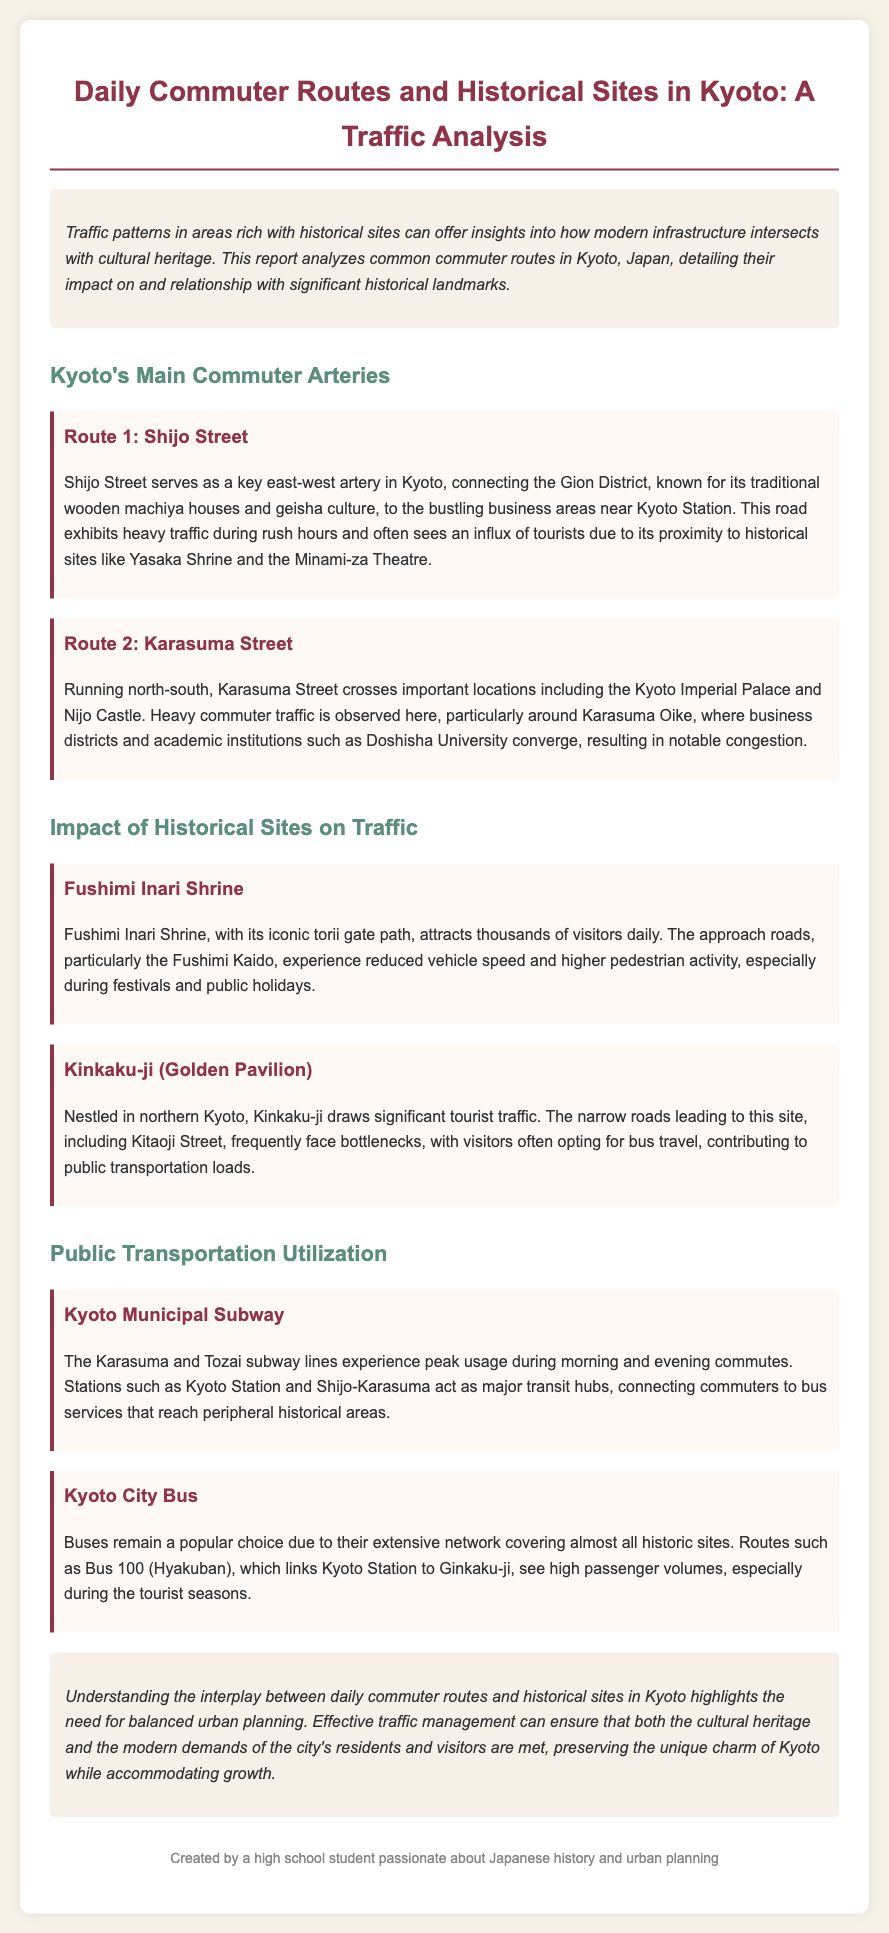What is the title of the report? The title is listed at the top of the document.
Answer: Daily Commuter Routes and Historical Sites in Kyoto: A Traffic Analysis What are the two main commuter arteries mentioned in the report? The report details the main commuter routes in Kyoto.
Answer: Shijo Street and Karasuma Street Which historical site attracts thousands of visitors daily? The document specifically notes visitor numbers for this location.
Answer: Fushimi Inari Shrine What is a significant impact of Kinkaku-ji on traffic? The report describes traffic conditions caused by this site.
Answer: Bottlenecks What public transportation system experiences peak usage during morning and evening commutes? The document mentions this transport system under public transportation utilization.
Answer: Kyoto Municipal Subway Why do buses remain a popular choice for tourists? The report explains the reason behind the popularity of buses.
Answer: Extensive network What is the significance of Shijo Street in commuter traffic? The report highlights its key role in connecting areas in Kyoto.
Answer: Key east-west artery How many subway lines are mentioned in the analysis? The document references two subway lines in the context of public transportation.
Answer: Two 